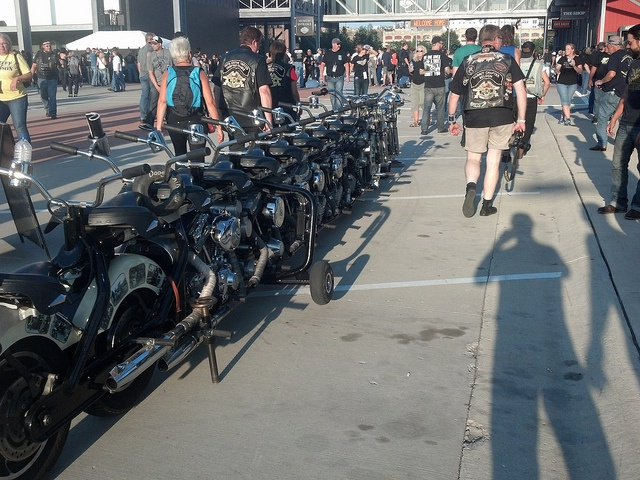Describe the objects in this image and their specific colors. I can see motorcycle in white, black, gray, purple, and darkgray tones, motorcycle in white, black, gray, darkblue, and blue tones, people in white, gray, black, lightgray, and tan tones, people in white, black, gray, and darkgray tones, and motorcycle in white, black, gray, darkblue, and blue tones in this image. 